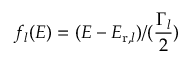<formula> <loc_0><loc_0><loc_500><loc_500>f _ { l } ( E ) = ( E - E _ { r , l } ) / ( \frac { \Gamma _ { l } } { 2 } )</formula> 